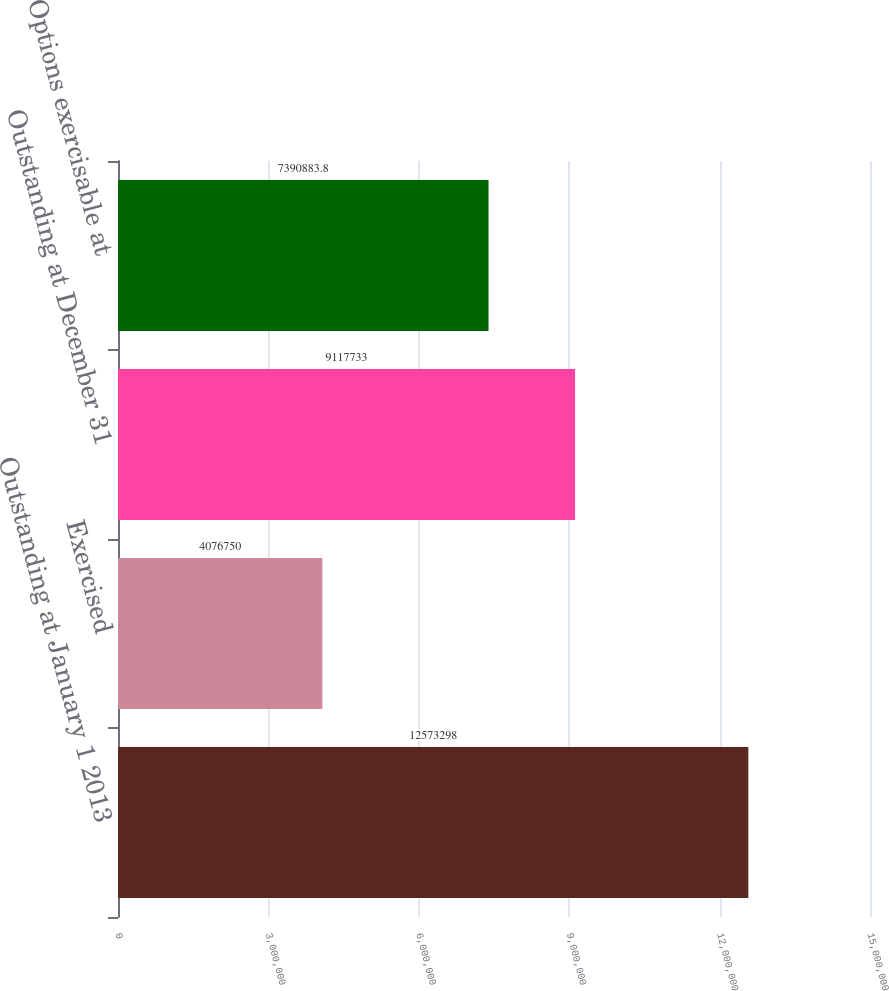Convert chart to OTSL. <chart><loc_0><loc_0><loc_500><loc_500><bar_chart><fcel>Outstanding at January 1 2013<fcel>Exercised<fcel>Outstanding at December 31<fcel>Options exercisable at<nl><fcel>1.25733e+07<fcel>4.07675e+06<fcel>9.11773e+06<fcel>7.39088e+06<nl></chart> 